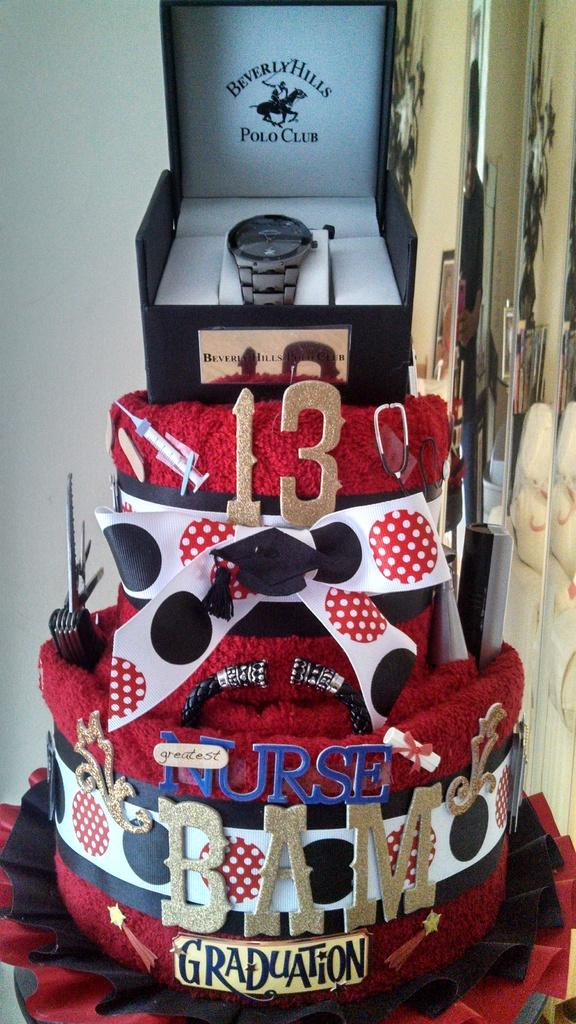<image>
Relay a brief, clear account of the picture shown. A graduation cake has a watch in a box on top that says Beverly Hills Polo Club. 